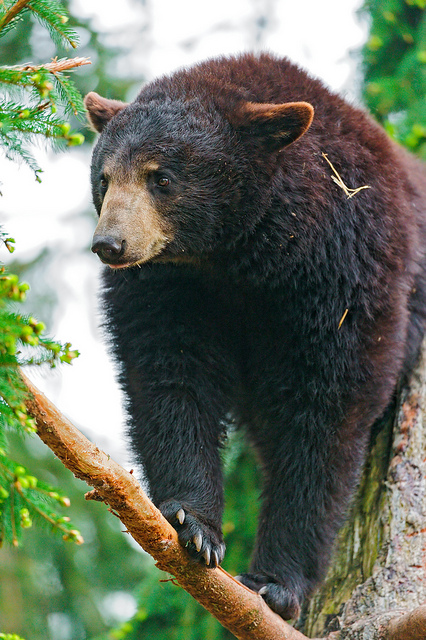How does the bear's fur help it in the wild? The bear's fur plays a crucial role in its survival in the wild. Firstly, it provides insulation, keeping the bear warm in cold weather and helping regulate body temperature. This thick fur also offers protection against environmental elements like rain, wind, and snow, as well as from insect bites and minor injuries. Additionally, the bear's dark fur can offer some camouflage in the dense forest, making it blend in with the shadows and helping it stay hidden from potential threats. Such natural adaptations are essential for the bear's ability to thrive in its natural habitat. Could this bear have any special abilities that humans should learn about? This bear, like many others, possesses some remarkable abilities that might surprise humans. One of its special skills is an incredible sense of smell, far superior to that of humans, allowing the bear to detect food sources or potential threats from a considerable distance. Bears are also strong swimmers and climbers, showcasing remarkable physical strength and agility. Moreover, they have a keen sense of curiosity and can learn quickly from their environment, adapting their behaviors to maximize opportunities for food and safety. These abilities highlight the bear's impressive adaptability and resourcefulness in the wild. Imagine this bear discovers a hidden treasure in the forest. What might happen next? Imagine Bruno the bear stumbled upon an ancient, hidden treasure chest buried beneath the forest floor. His sharp claws carefully dug around the wooden chest, revealing its intricate carvings. With a curious nudge, he managed to pry it open, and inside glimmered a multitude of shiny, peculiar objects unlike anything he'd ever seen. Among the treasure were ancient coins, sparkling gems, and mysterious artifacts. Bruno's eyes widened with wonder as he realized the significance of his discovery. The forest began whispering tales of the chest's origins, and Bruno felt a surge of determination. Understanding that this treasure could change his forest home forever, Bruno decided to protect it. He called upon his woodland friends—wise old owls, cunning foxes, and playful raccoons—to help guard the treasure. Together, they vowed to keep the forest's secrets safe, ensuring that its magic remained undisturbed by the outside world, thus beginning a legend that would be passed down through generations. From a realistic perspective, how do bears behave when they come across something unknown or unusual in the wild? When bears encounter something unknown or unusual in the wild, they typically exhibit cautious curiosity. Initially, a bear might approach the object slowly and sniff around it to gather information through its keen sense of smell. If the object doesn't pose an immediate threat, the bear may inspect it further by pawing at it or nudging it with its nose. However, if the bear senses danger or something unfamiliar that it cannot ascertain, it might retreat to a safer distance and observe from afar. This cautious yet inquisitive behavior helps bears avoid potential dangers while still satisfying their innate curiosity and learning about their environment. What might a short, realistic scenario be where the bear climbs a tree? One afternoon, while foraging for food, the bear catches the scent of fresh berries high up in a tree. Driven by hunger and the promise of a treat, the bear expertly climbs the tree, using its strong claws to grip the bark. It carefully navigates the branches until it reaches the cluster of ripe berries, eating them contentedly while perched safely above the forest floor. 